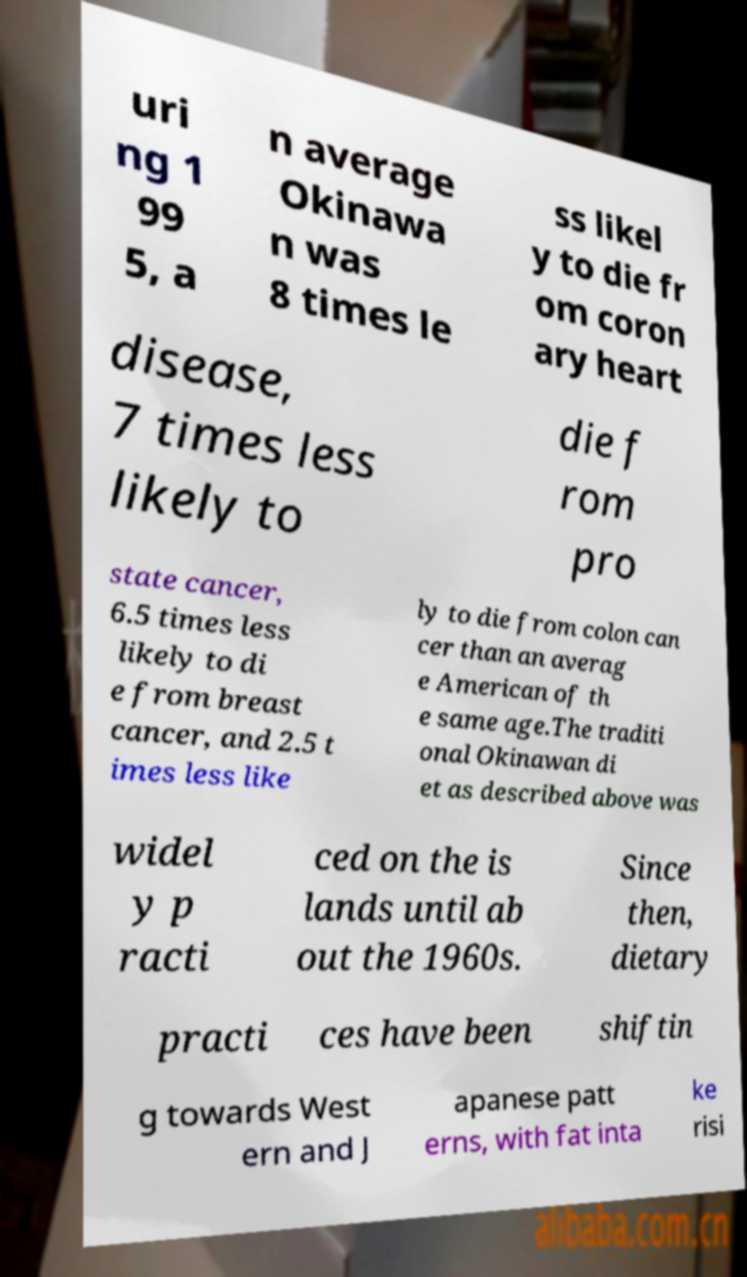Please read and relay the text visible in this image. What does it say? uri ng 1 99 5, a n average Okinawa n was 8 times le ss likel y to die fr om coron ary heart disease, 7 times less likely to die f rom pro state cancer, 6.5 times less likely to di e from breast cancer, and 2.5 t imes less like ly to die from colon can cer than an averag e American of th e same age.The traditi onal Okinawan di et as described above was widel y p racti ced on the is lands until ab out the 1960s. Since then, dietary practi ces have been shiftin g towards West ern and J apanese patt erns, with fat inta ke risi 